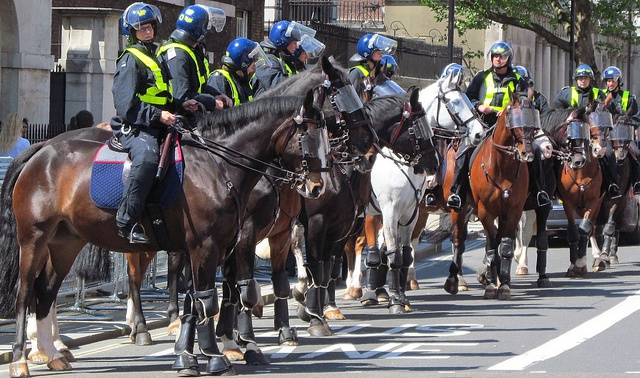Describe the objects in this image and their specific colors. I can see horse in black, gray, darkgray, and maroon tones, people in black and gray tones, horse in black, white, darkgray, and gray tones, horse in black, maroon, gray, and brown tones, and horse in black, maroon, gray, and darkgray tones in this image. 